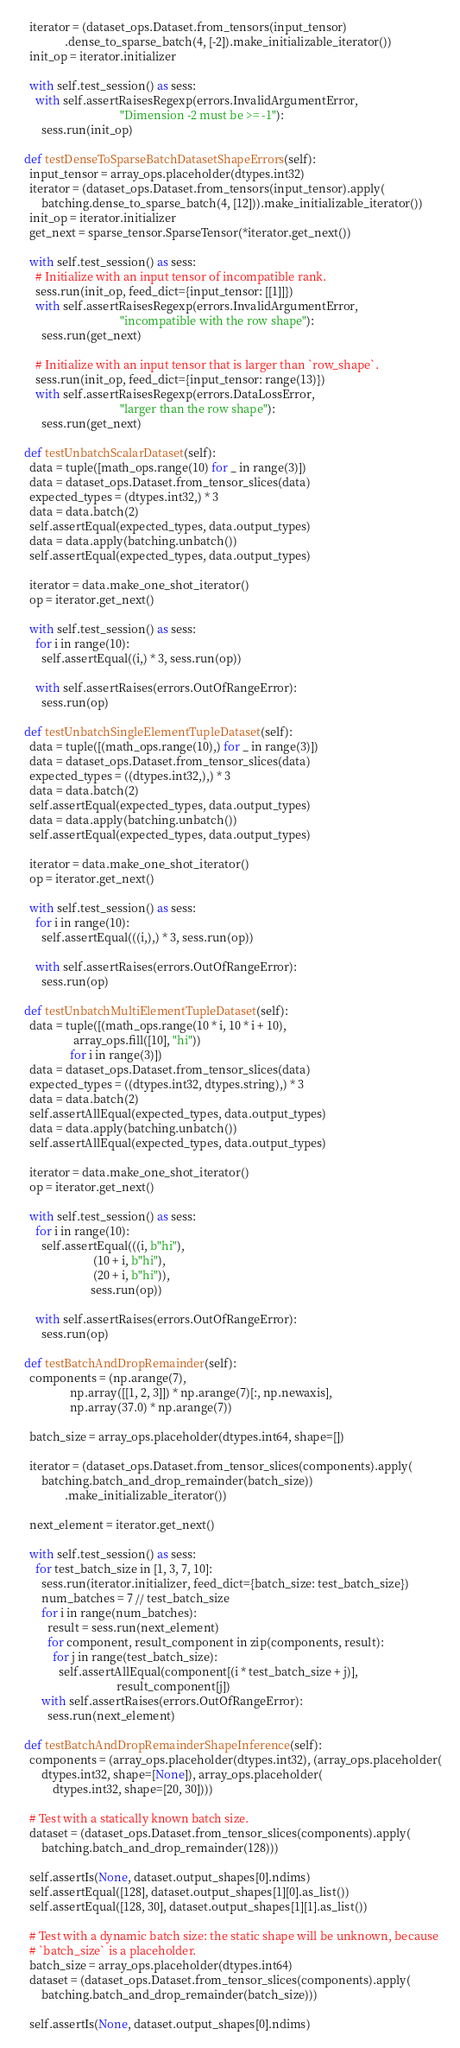Convert code to text. <code><loc_0><loc_0><loc_500><loc_500><_Python_>    iterator = (dataset_ops.Dataset.from_tensors(input_tensor)
                .dense_to_sparse_batch(4, [-2]).make_initializable_iterator())
    init_op = iterator.initializer

    with self.test_session() as sess:
      with self.assertRaisesRegexp(errors.InvalidArgumentError,
                                   "Dimension -2 must be >= -1"):
        sess.run(init_op)

  def testDenseToSparseBatchDatasetShapeErrors(self):
    input_tensor = array_ops.placeholder(dtypes.int32)
    iterator = (dataset_ops.Dataset.from_tensors(input_tensor).apply(
        batching.dense_to_sparse_batch(4, [12])).make_initializable_iterator())
    init_op = iterator.initializer
    get_next = sparse_tensor.SparseTensor(*iterator.get_next())

    with self.test_session() as sess:
      # Initialize with an input tensor of incompatible rank.
      sess.run(init_op, feed_dict={input_tensor: [[1]]})
      with self.assertRaisesRegexp(errors.InvalidArgumentError,
                                   "incompatible with the row shape"):
        sess.run(get_next)

      # Initialize with an input tensor that is larger than `row_shape`.
      sess.run(init_op, feed_dict={input_tensor: range(13)})
      with self.assertRaisesRegexp(errors.DataLossError,
                                   "larger than the row shape"):
        sess.run(get_next)

  def testUnbatchScalarDataset(self):
    data = tuple([math_ops.range(10) for _ in range(3)])
    data = dataset_ops.Dataset.from_tensor_slices(data)
    expected_types = (dtypes.int32,) * 3
    data = data.batch(2)
    self.assertEqual(expected_types, data.output_types)
    data = data.apply(batching.unbatch())
    self.assertEqual(expected_types, data.output_types)

    iterator = data.make_one_shot_iterator()
    op = iterator.get_next()

    with self.test_session() as sess:
      for i in range(10):
        self.assertEqual((i,) * 3, sess.run(op))

      with self.assertRaises(errors.OutOfRangeError):
        sess.run(op)

  def testUnbatchSingleElementTupleDataset(self):
    data = tuple([(math_ops.range(10),) for _ in range(3)])
    data = dataset_ops.Dataset.from_tensor_slices(data)
    expected_types = ((dtypes.int32,),) * 3
    data = data.batch(2)
    self.assertEqual(expected_types, data.output_types)
    data = data.apply(batching.unbatch())
    self.assertEqual(expected_types, data.output_types)

    iterator = data.make_one_shot_iterator()
    op = iterator.get_next()

    with self.test_session() as sess:
      for i in range(10):
        self.assertEqual(((i,),) * 3, sess.run(op))

      with self.assertRaises(errors.OutOfRangeError):
        sess.run(op)

  def testUnbatchMultiElementTupleDataset(self):
    data = tuple([(math_ops.range(10 * i, 10 * i + 10),
                   array_ops.fill([10], "hi"))
                  for i in range(3)])
    data = dataset_ops.Dataset.from_tensor_slices(data)
    expected_types = ((dtypes.int32, dtypes.string),) * 3
    data = data.batch(2)
    self.assertAllEqual(expected_types, data.output_types)
    data = data.apply(batching.unbatch())
    self.assertAllEqual(expected_types, data.output_types)

    iterator = data.make_one_shot_iterator()
    op = iterator.get_next()

    with self.test_session() as sess:
      for i in range(10):
        self.assertEqual(((i, b"hi"),
                          (10 + i, b"hi"),
                          (20 + i, b"hi")),
                         sess.run(op))

      with self.assertRaises(errors.OutOfRangeError):
        sess.run(op)

  def testBatchAndDropRemainder(self):
    components = (np.arange(7),
                  np.array([[1, 2, 3]]) * np.arange(7)[:, np.newaxis],
                  np.array(37.0) * np.arange(7))

    batch_size = array_ops.placeholder(dtypes.int64, shape=[])

    iterator = (dataset_ops.Dataset.from_tensor_slices(components).apply(
        batching.batch_and_drop_remainder(batch_size))
                .make_initializable_iterator())

    next_element = iterator.get_next()

    with self.test_session() as sess:
      for test_batch_size in [1, 3, 7, 10]:
        sess.run(iterator.initializer, feed_dict={batch_size: test_batch_size})
        num_batches = 7 // test_batch_size
        for i in range(num_batches):
          result = sess.run(next_element)
          for component, result_component in zip(components, result):
            for j in range(test_batch_size):
              self.assertAllEqual(component[(i * test_batch_size + j)],
                                  result_component[j])
        with self.assertRaises(errors.OutOfRangeError):
          sess.run(next_element)

  def testBatchAndDropRemainderShapeInference(self):
    components = (array_ops.placeholder(dtypes.int32), (array_ops.placeholder(
        dtypes.int32, shape=[None]), array_ops.placeholder(
            dtypes.int32, shape=[20, 30])))

    # Test with a statically known batch size.
    dataset = (dataset_ops.Dataset.from_tensor_slices(components).apply(
        batching.batch_and_drop_remainder(128)))

    self.assertIs(None, dataset.output_shapes[0].ndims)
    self.assertEqual([128], dataset.output_shapes[1][0].as_list())
    self.assertEqual([128, 30], dataset.output_shapes[1][1].as_list())

    # Test with a dynamic batch size: the static shape will be unknown, because
    # `batch_size` is a placeholder.
    batch_size = array_ops.placeholder(dtypes.int64)
    dataset = (dataset_ops.Dataset.from_tensor_slices(components).apply(
        batching.batch_and_drop_remainder(batch_size)))

    self.assertIs(None, dataset.output_shapes[0].ndims)</code> 